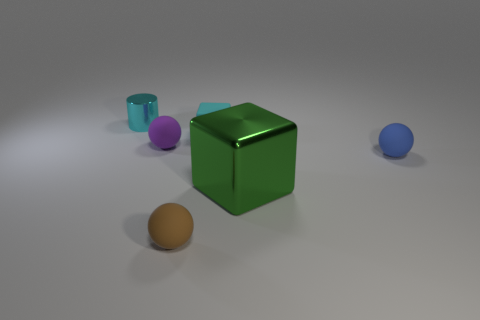Is there a source of light in this image, and how can you tell? Yes, there appears to be a light source above the objects, slightly off to the right, as evidenced by the highlights and shadows in the image. The green cube reflects light on its upper side and casts a shadow on the ground to its left, which helps to deduce the light's positioning. 